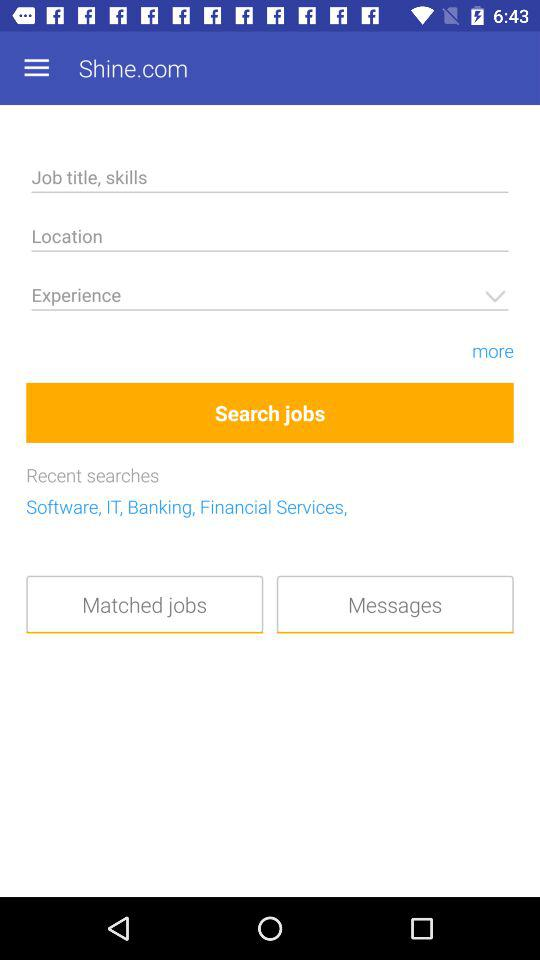What are the recent searches? The recent searches are for "Software", "IT", "Banking" and "Financial Services". 